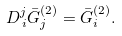<formula> <loc_0><loc_0><loc_500><loc_500>D _ { \, i } ^ { j } \bar { G } _ { j } ^ { ( 2 ) } = \bar { G } _ { i } ^ { ( 2 ) } .</formula> 